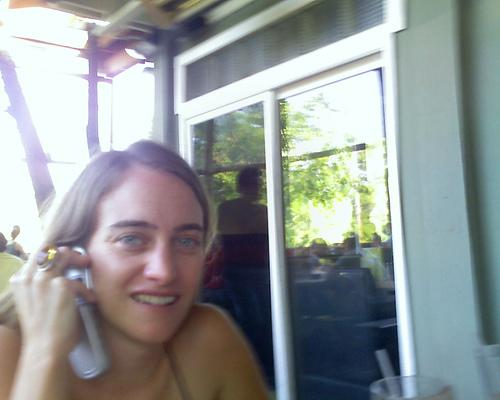Where is she most likely having a conversation on her cellphone?

Choices:
A) street
B) park
C) restaurant
D) school restaurant 